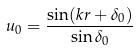Convert formula to latex. <formula><loc_0><loc_0><loc_500><loc_500>u _ { 0 } = \frac { \sin ( k r + \delta _ { 0 } ) } { \sin \delta _ { 0 } }</formula> 